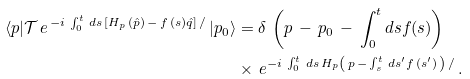<formula> <loc_0><loc_0><loc_500><loc_500>\langle p | \mathcal { T } \, e ^ { \, - i \, \int _ { 0 } ^ { t } \, d s \, \left [ H _ { p } \, ( \hat { p } ) \, - \, f \, ( s ) \hat { q } \right ] \, / \, } | p _ { 0 } \rangle & = \delta \, \left ( p \, - \, p _ { 0 } \, - \, \int _ { 0 } ^ { t } d s f ( s ) \right ) \\ & \times \, e ^ { - i \, \int _ { 0 } ^ { t } \, d s \, H _ { p } \left ( \, p \, - \, \int _ { s } ^ { t } \, d s ^ { \prime } f \, ( s ^ { \prime } ) \, \right ) \, / \, } .</formula> 